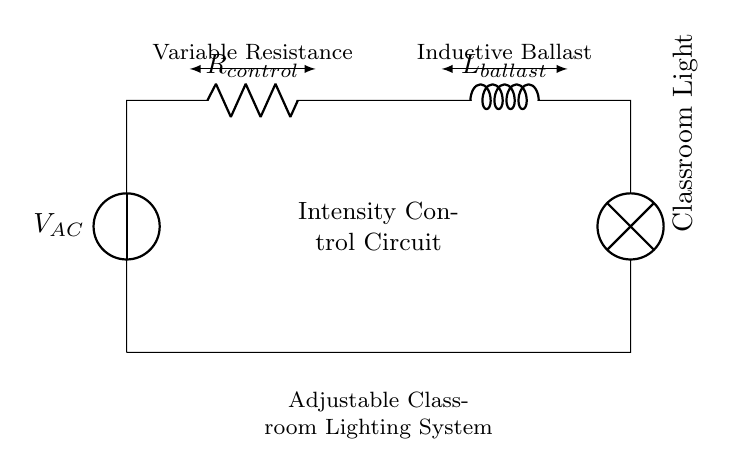What is the main purpose of the resistor in this circuit? The resistor serves to control the amount of current flowing through the circuit, which in turn adjusts the intensity of the classroom light.
Answer: Current control What component is labeled as the 'lamp'? The lamp in the circuit provides the actual light output for the classroom, representing the lighting fixture that illuminates the space.
Answer: Classroom light What type of circuit is this? The circuit is a Resistor-Inductor circuit specifically designed for controlling lighting intensity through the use of variable resistance and inductive ballast.
Answer: Resistor-Inductor circuit What does the inductor represent in this circuit? The inductor represents an inductive ballast that helps regulate the current and provides a smoother operation for the light by reducing flicker.
Answer: Inductive ballast How does the variable resistance affect the lighting intensity? By adjusting the variable resistance, the current flowing to the lamp can be increased or decreased, allowing for finer control over the lighting intensity in classrooms.
Answer: Adjusts lighting intensity What is the relationship between inductance and current in this circuit? In an inductive circuit, as the current through the coil changes, the inductor creates a magnetic field that opposes sudden changes in current, thus impacting how quickly the light can change in brightness.
Answer: Opposes changes in current 